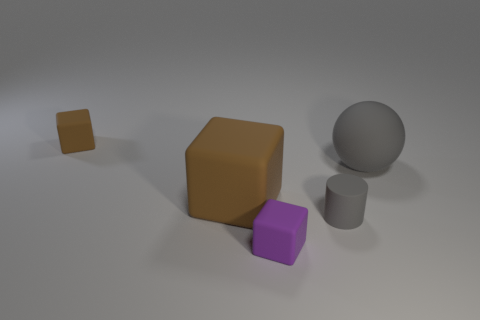Subtract all cyan balls. How many brown cubes are left? 2 Subtract all purple blocks. How many blocks are left? 2 Add 4 gray rubber objects. How many objects exist? 9 Subtract all balls. How many objects are left? 4 Subtract all brown matte objects. Subtract all big gray spheres. How many objects are left? 2 Add 4 large spheres. How many large spheres are left? 5 Add 3 big matte objects. How many big matte objects exist? 5 Subtract 0 red cylinders. How many objects are left? 5 